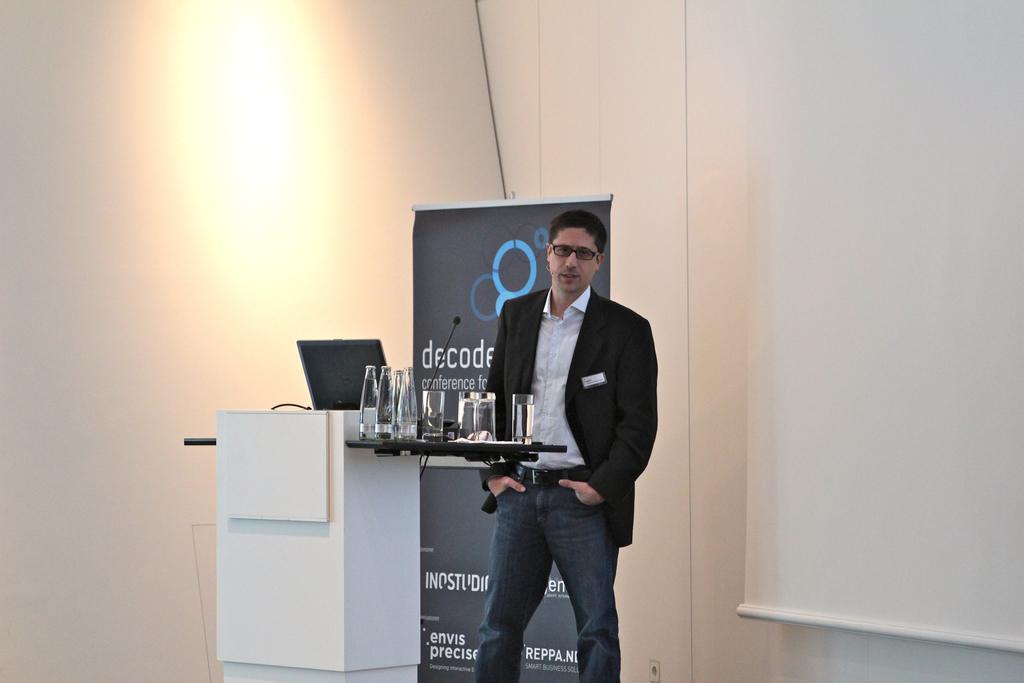Could you give a brief overview of what you see in this image? In the picture we can see a person standing in a black blazer, white shirt, and keeping his hands in the trouser pockets and in him we can see a desk with a laptop and some part of the desk with glasses and bottles and behind the man we can see a hoarding with some advertisement and beside him we can see a part of the screen near the wall. 